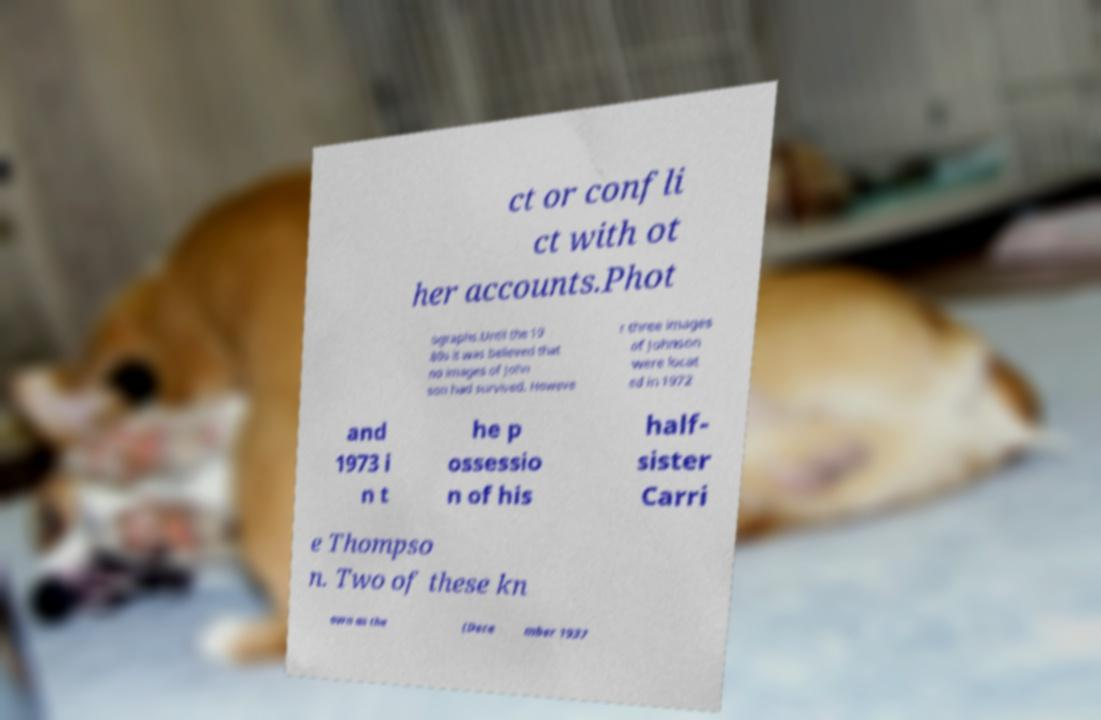Can you read and provide the text displayed in the image?This photo seems to have some interesting text. Can you extract and type it out for me? ct or confli ct with ot her accounts.Phot ographs.Until the 19 80s it was believed that no images of John son had survived. Howeve r three images of Johnson were locat ed in 1972 and 1973 i n t he p ossessio n of his half- sister Carri e Thompso n. Two of these kn own as the (Dece mber 1937 